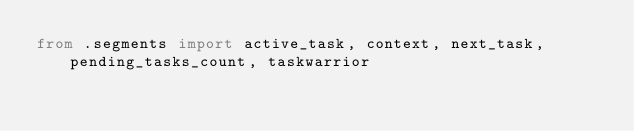<code> <loc_0><loc_0><loc_500><loc_500><_Python_>from .segments import active_task, context, next_task, pending_tasks_count, taskwarrior
</code> 